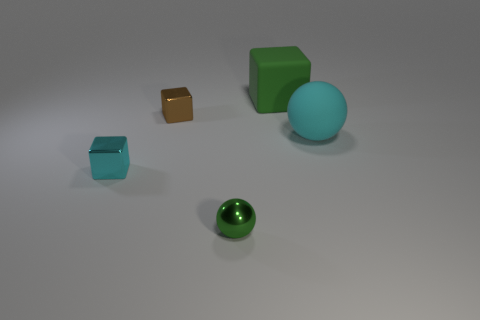Add 2 big green matte blocks. How many objects exist? 7 Subtract all spheres. How many objects are left? 3 Add 2 small yellow shiny things. How many small yellow shiny things exist? 2 Subtract 1 green balls. How many objects are left? 4 Subtract all small green shiny spheres. Subtract all small green metal spheres. How many objects are left? 3 Add 1 cyan metal blocks. How many cyan metal blocks are left? 2 